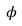<formula> <loc_0><loc_0><loc_500><loc_500>\phi</formula> 